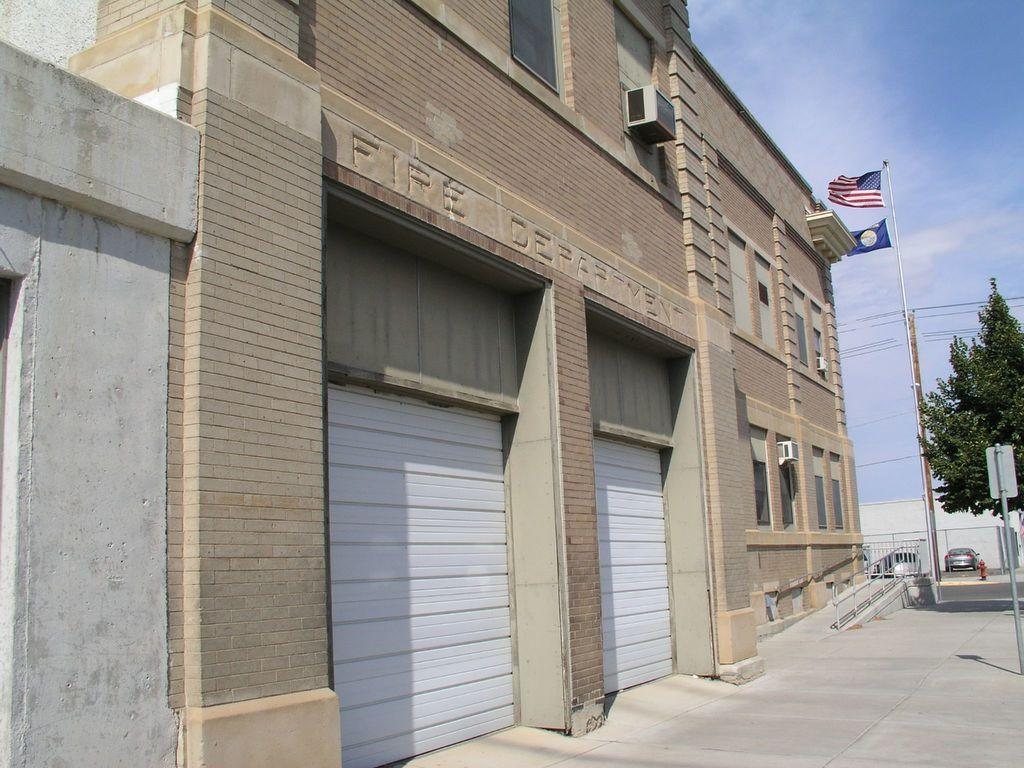What type of view is shown in the image? The image is an outside view. What structure can be seen in the image? There is a building in the image. What is located on the right side of the image? There is a tree, a flag, and a pole on the right side of the image. What is on the ground in the image? There is a car on the ground in the image. What is visible at the top of the image? The sky is visible at the top of the image. What type of debt is being discussed in the image? There is no mention of debt in the image; it features an outside view with a building, tree, flag, pole, car, and sky. How many coaches are visible in the image? There are no coaches present in the image. 